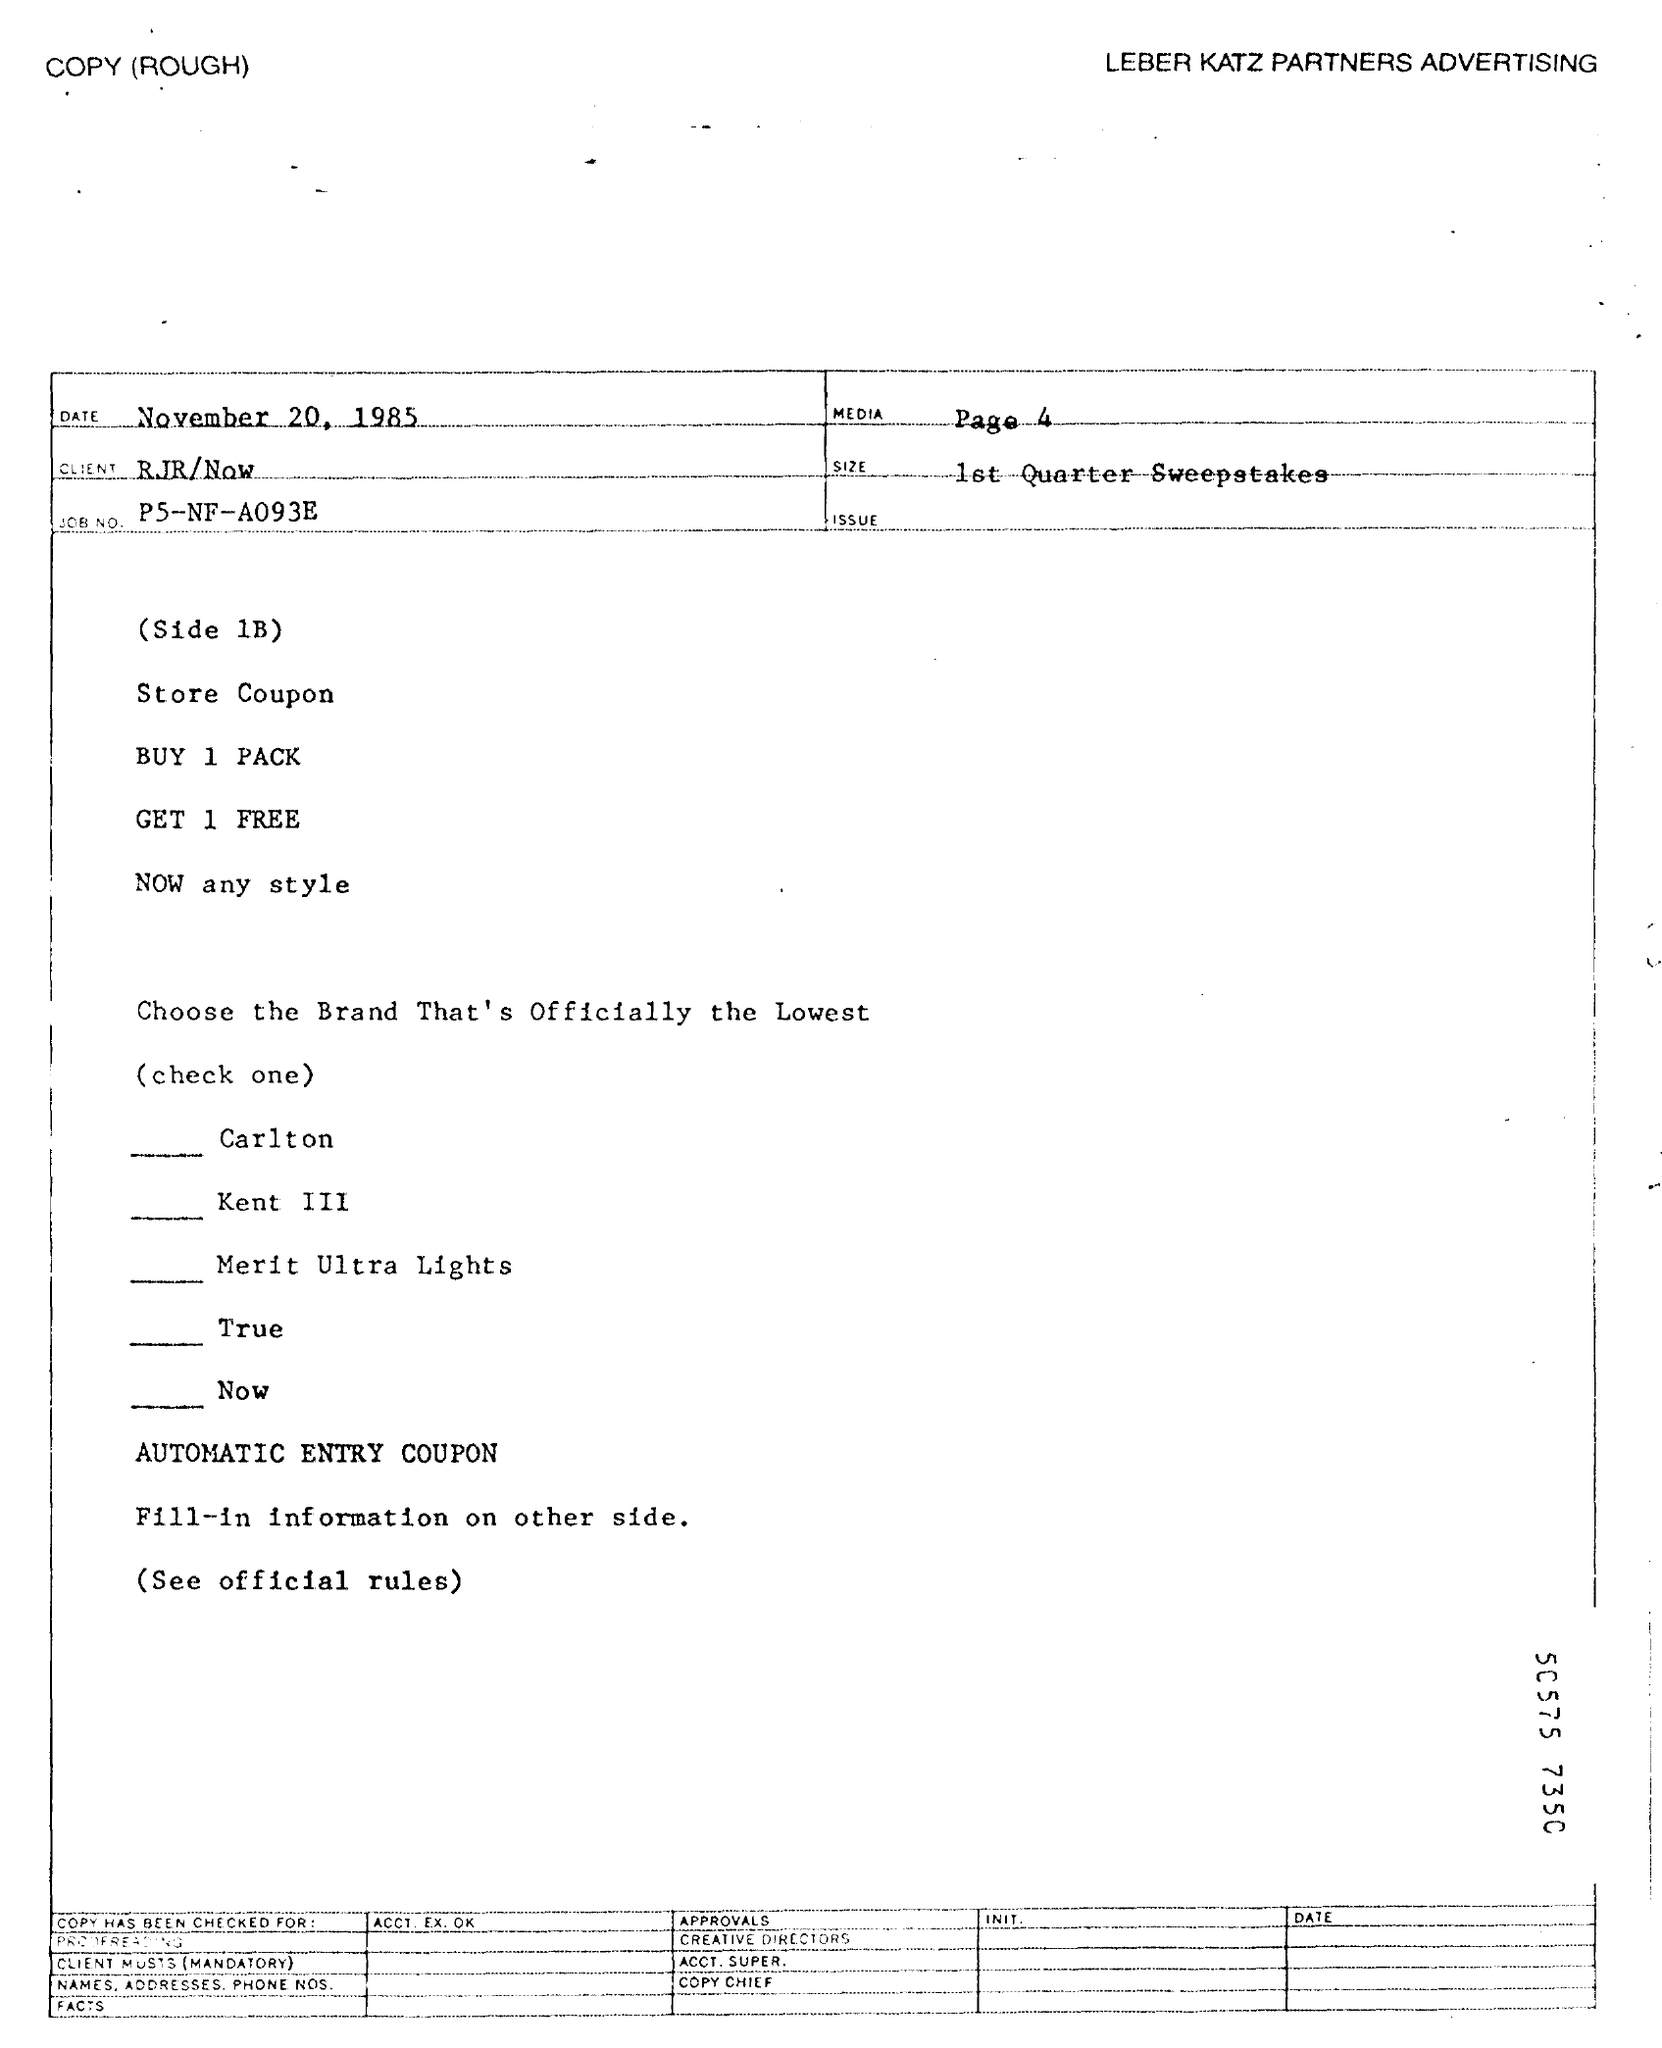Which is the advertising firm mentioned?
Ensure brevity in your answer.  LEBER KATZ PARTNERS ADVERTISING. When is the document dated?
Give a very brief answer. November 20, 1985. On which page is MEDIA?
Ensure brevity in your answer.  Page 4. Who is the client?
Provide a short and direct response. RJR/Now. What is the JOB NO.?
Make the answer very short. P5-NF-A093E. 